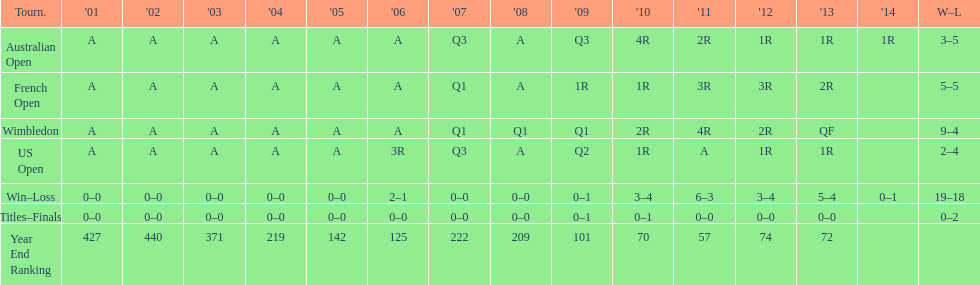Which year end ranking was higher, 2004 or 2011? 2011. Can you give me this table as a dict? {'header': ['Tourn.', "'01", "'02", "'03", "'04", "'05", "'06", "'07", "'08", "'09", "'10", "'11", "'12", "'13", "'14", 'W–L'], 'rows': [['Australian Open', 'A', 'A', 'A', 'A', 'A', 'A', 'Q3', 'A', 'Q3', '4R', '2R', '1R', '1R', '1R', '3–5'], ['French Open', 'A', 'A', 'A', 'A', 'A', 'A', 'Q1', 'A', '1R', '1R', '3R', '3R', '2R', '', '5–5'], ['Wimbledon', 'A', 'A', 'A', 'A', 'A', 'A', 'Q1', 'Q1', 'Q1', '2R', '4R', '2R', 'QF', '', '9–4'], ['US Open', 'A', 'A', 'A', 'A', 'A', '3R', 'Q3', 'A', 'Q2', '1R', 'A', '1R', '1R', '', '2–4'], ['Win–Loss', '0–0', '0–0', '0–0', '0–0', '0–0', '2–1', '0–0', '0–0', '0–1', '3–4', '6–3', '3–4', '5–4', '0–1', '19–18'], ['Titles–Finals', '0–0', '0–0', '0–0', '0–0', '0–0', '0–0', '0–0', '0–0', '0–1', '0–1', '0–0', '0–0', '0–0', '', '0–2'], ['Year End Ranking', '427', '440', '371', '219', '142', '125', '222', '209', '101', '70', '57', '74', '72', '', '']]} 